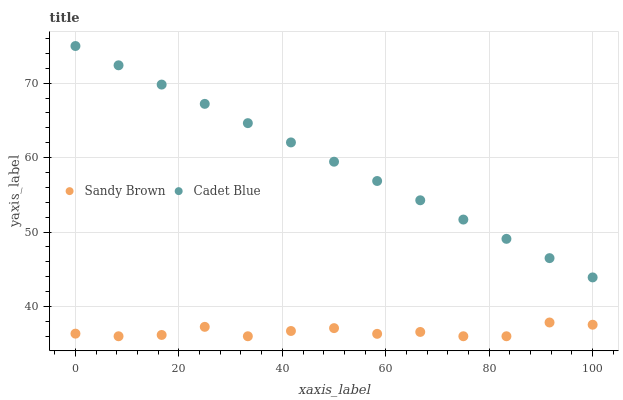Does Sandy Brown have the minimum area under the curve?
Answer yes or no. Yes. Does Cadet Blue have the maximum area under the curve?
Answer yes or no. Yes. Does Sandy Brown have the maximum area under the curve?
Answer yes or no. No. Is Cadet Blue the smoothest?
Answer yes or no. Yes. Is Sandy Brown the roughest?
Answer yes or no. Yes. Is Sandy Brown the smoothest?
Answer yes or no. No. Does Sandy Brown have the lowest value?
Answer yes or no. Yes. Does Cadet Blue have the highest value?
Answer yes or no. Yes. Does Sandy Brown have the highest value?
Answer yes or no. No. Is Sandy Brown less than Cadet Blue?
Answer yes or no. Yes. Is Cadet Blue greater than Sandy Brown?
Answer yes or no. Yes. Does Sandy Brown intersect Cadet Blue?
Answer yes or no. No. 